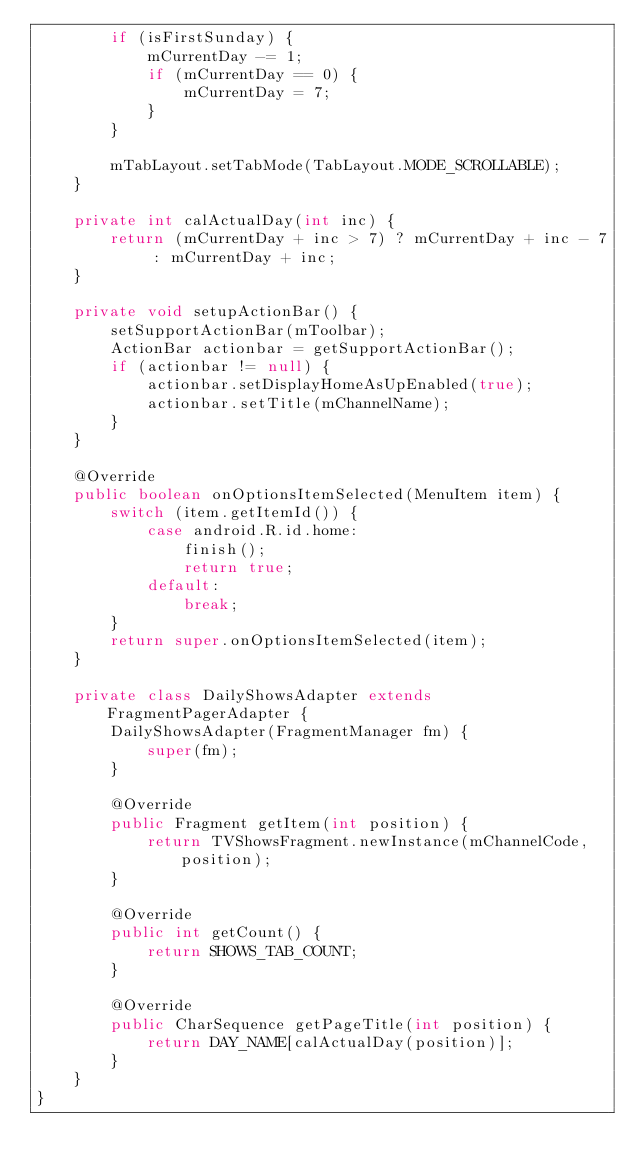Convert code to text. <code><loc_0><loc_0><loc_500><loc_500><_Java_>        if (isFirstSunday) {
            mCurrentDay -= 1;
            if (mCurrentDay == 0) {
                mCurrentDay = 7;
            }
        }

        mTabLayout.setTabMode(TabLayout.MODE_SCROLLABLE);
    }

    private int calActualDay(int inc) {
        return (mCurrentDay + inc > 7) ? mCurrentDay + inc - 7 : mCurrentDay + inc;
    }

    private void setupActionBar() {
        setSupportActionBar(mToolbar);
        ActionBar actionbar = getSupportActionBar();
        if (actionbar != null) {
            actionbar.setDisplayHomeAsUpEnabled(true);
            actionbar.setTitle(mChannelName);
        }
    }

    @Override
    public boolean onOptionsItemSelected(MenuItem item) {
        switch (item.getItemId()) {
            case android.R.id.home:
                finish();
                return true;
            default:
                break;
        }
        return super.onOptionsItemSelected(item);
    }

    private class DailyShowsAdapter extends FragmentPagerAdapter {
        DailyShowsAdapter(FragmentManager fm) {
            super(fm);
        }

        @Override
        public Fragment getItem(int position) {
            return TVShowsFragment.newInstance(mChannelCode, position);
        }

        @Override
        public int getCount() {
            return SHOWS_TAB_COUNT;
        }

        @Override
        public CharSequence getPageTitle(int position) {
            return DAY_NAME[calActualDay(position)];
        }
    }
}
</code> 